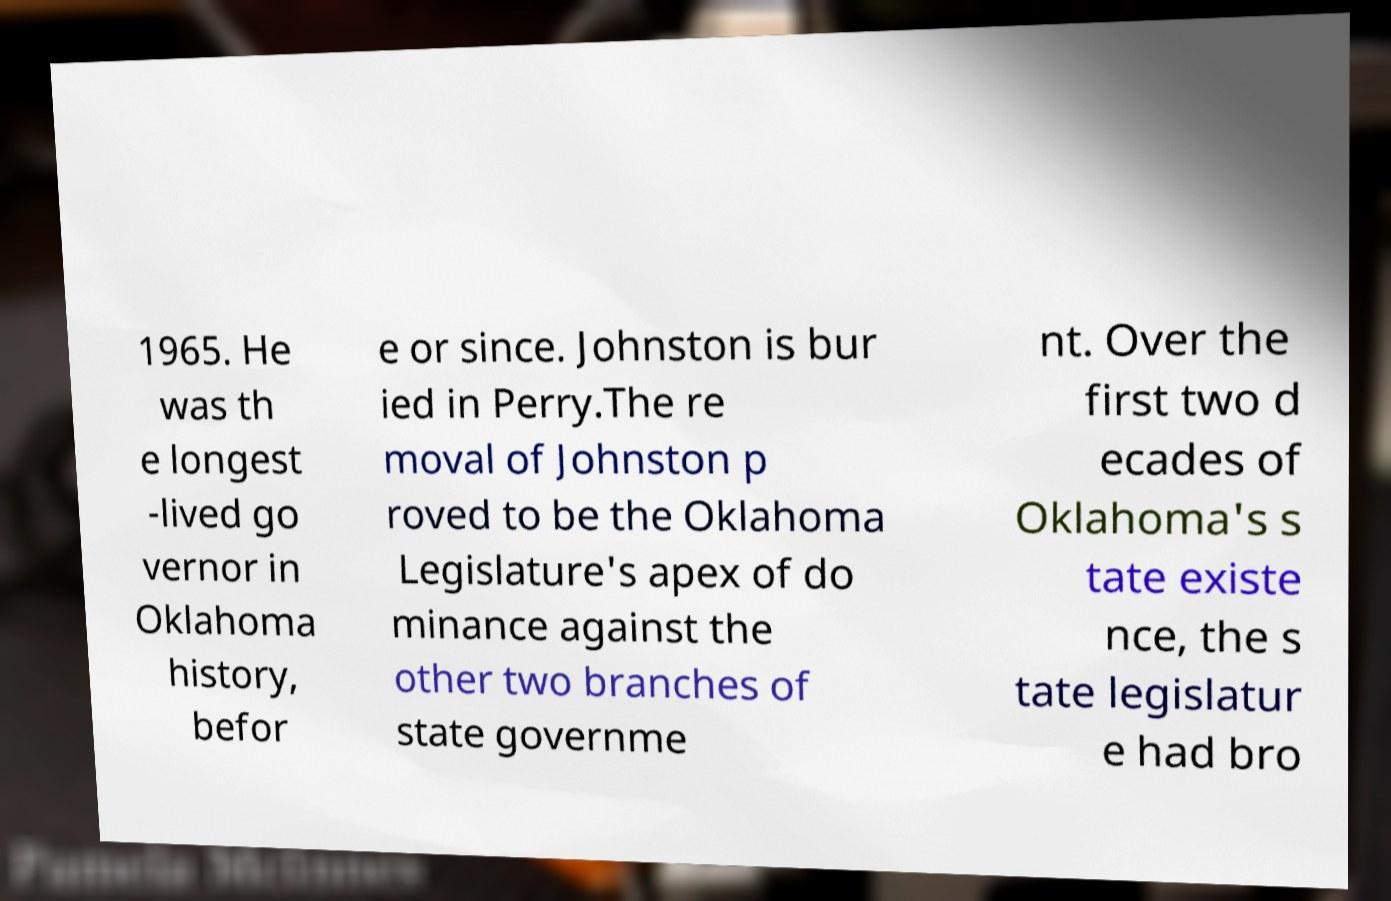Please read and relay the text visible in this image. What does it say? 1965. He was th e longest -lived go vernor in Oklahoma history, befor e or since. Johnston is bur ied in Perry.The re moval of Johnston p roved to be the Oklahoma Legislature's apex of do minance against the other two branches of state governme nt. Over the first two d ecades of Oklahoma's s tate existe nce, the s tate legislatur e had bro 